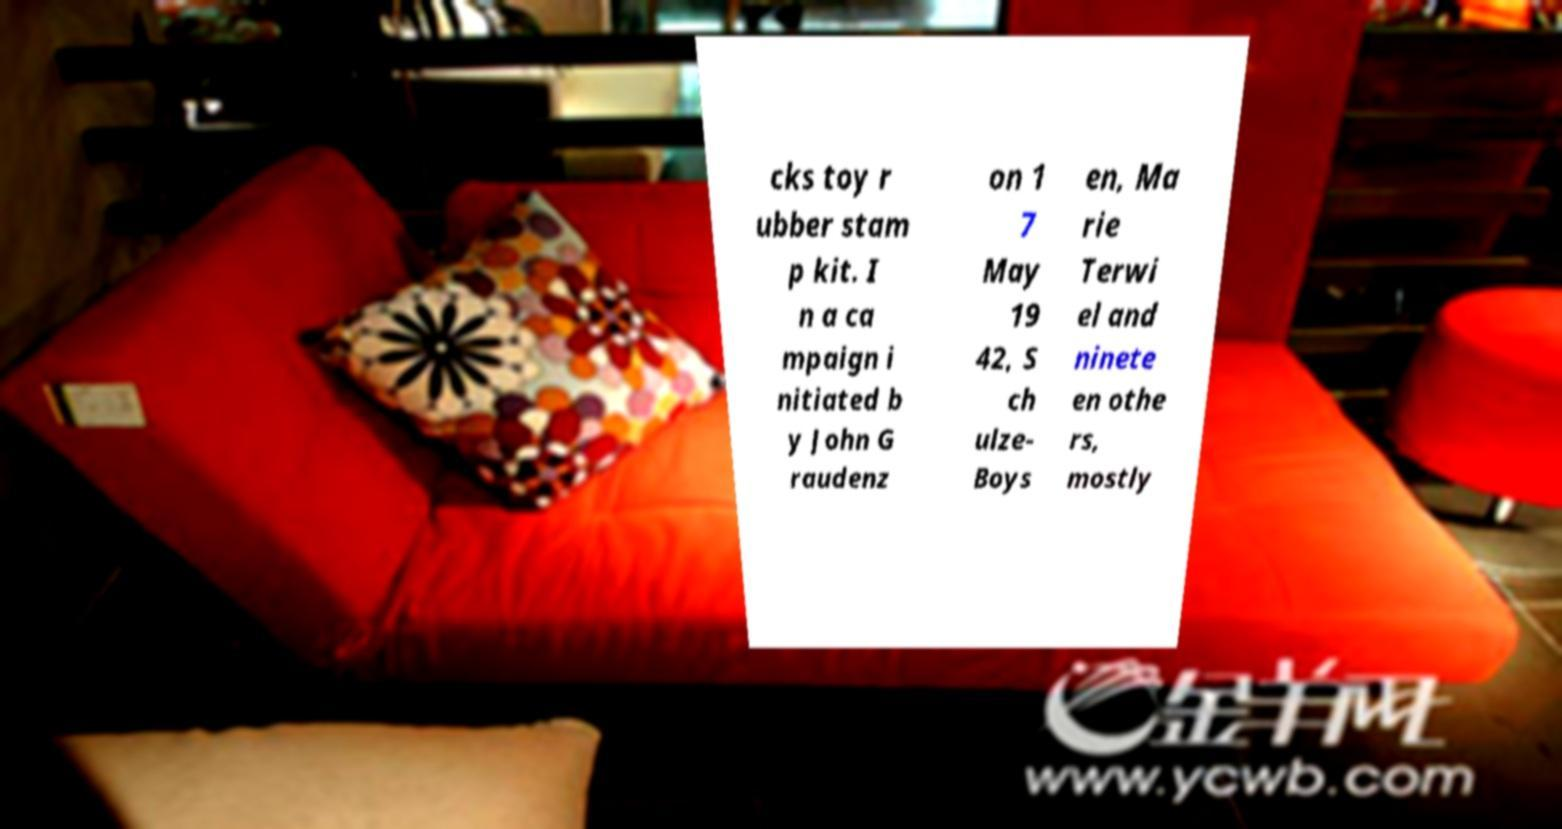What messages or text are displayed in this image? I need them in a readable, typed format. cks toy r ubber stam p kit. I n a ca mpaign i nitiated b y John G raudenz on 1 7 May 19 42, S ch ulze- Boys en, Ma rie Terwi el and ninete en othe rs, mostly 